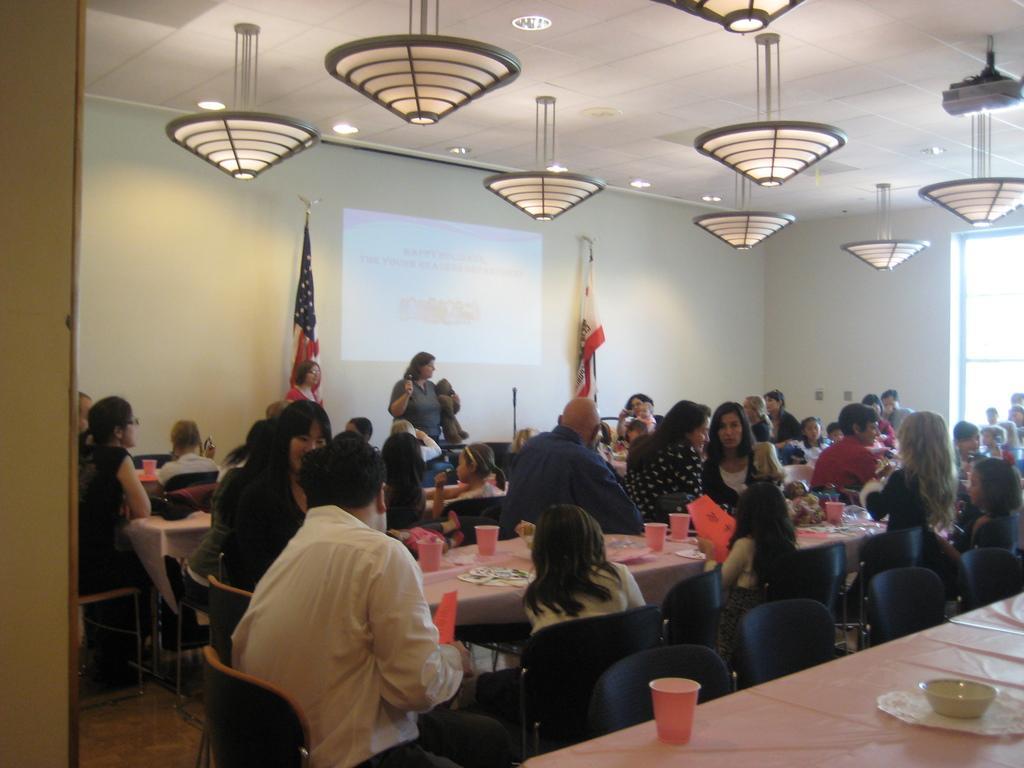Could you give a brief overview of what you see in this image? This picture describes about group of people few are seated on the chair and few are standing, in front of them we can see cups, plates on the table, and also we can see flags, on top of them we can find couple of lights. 